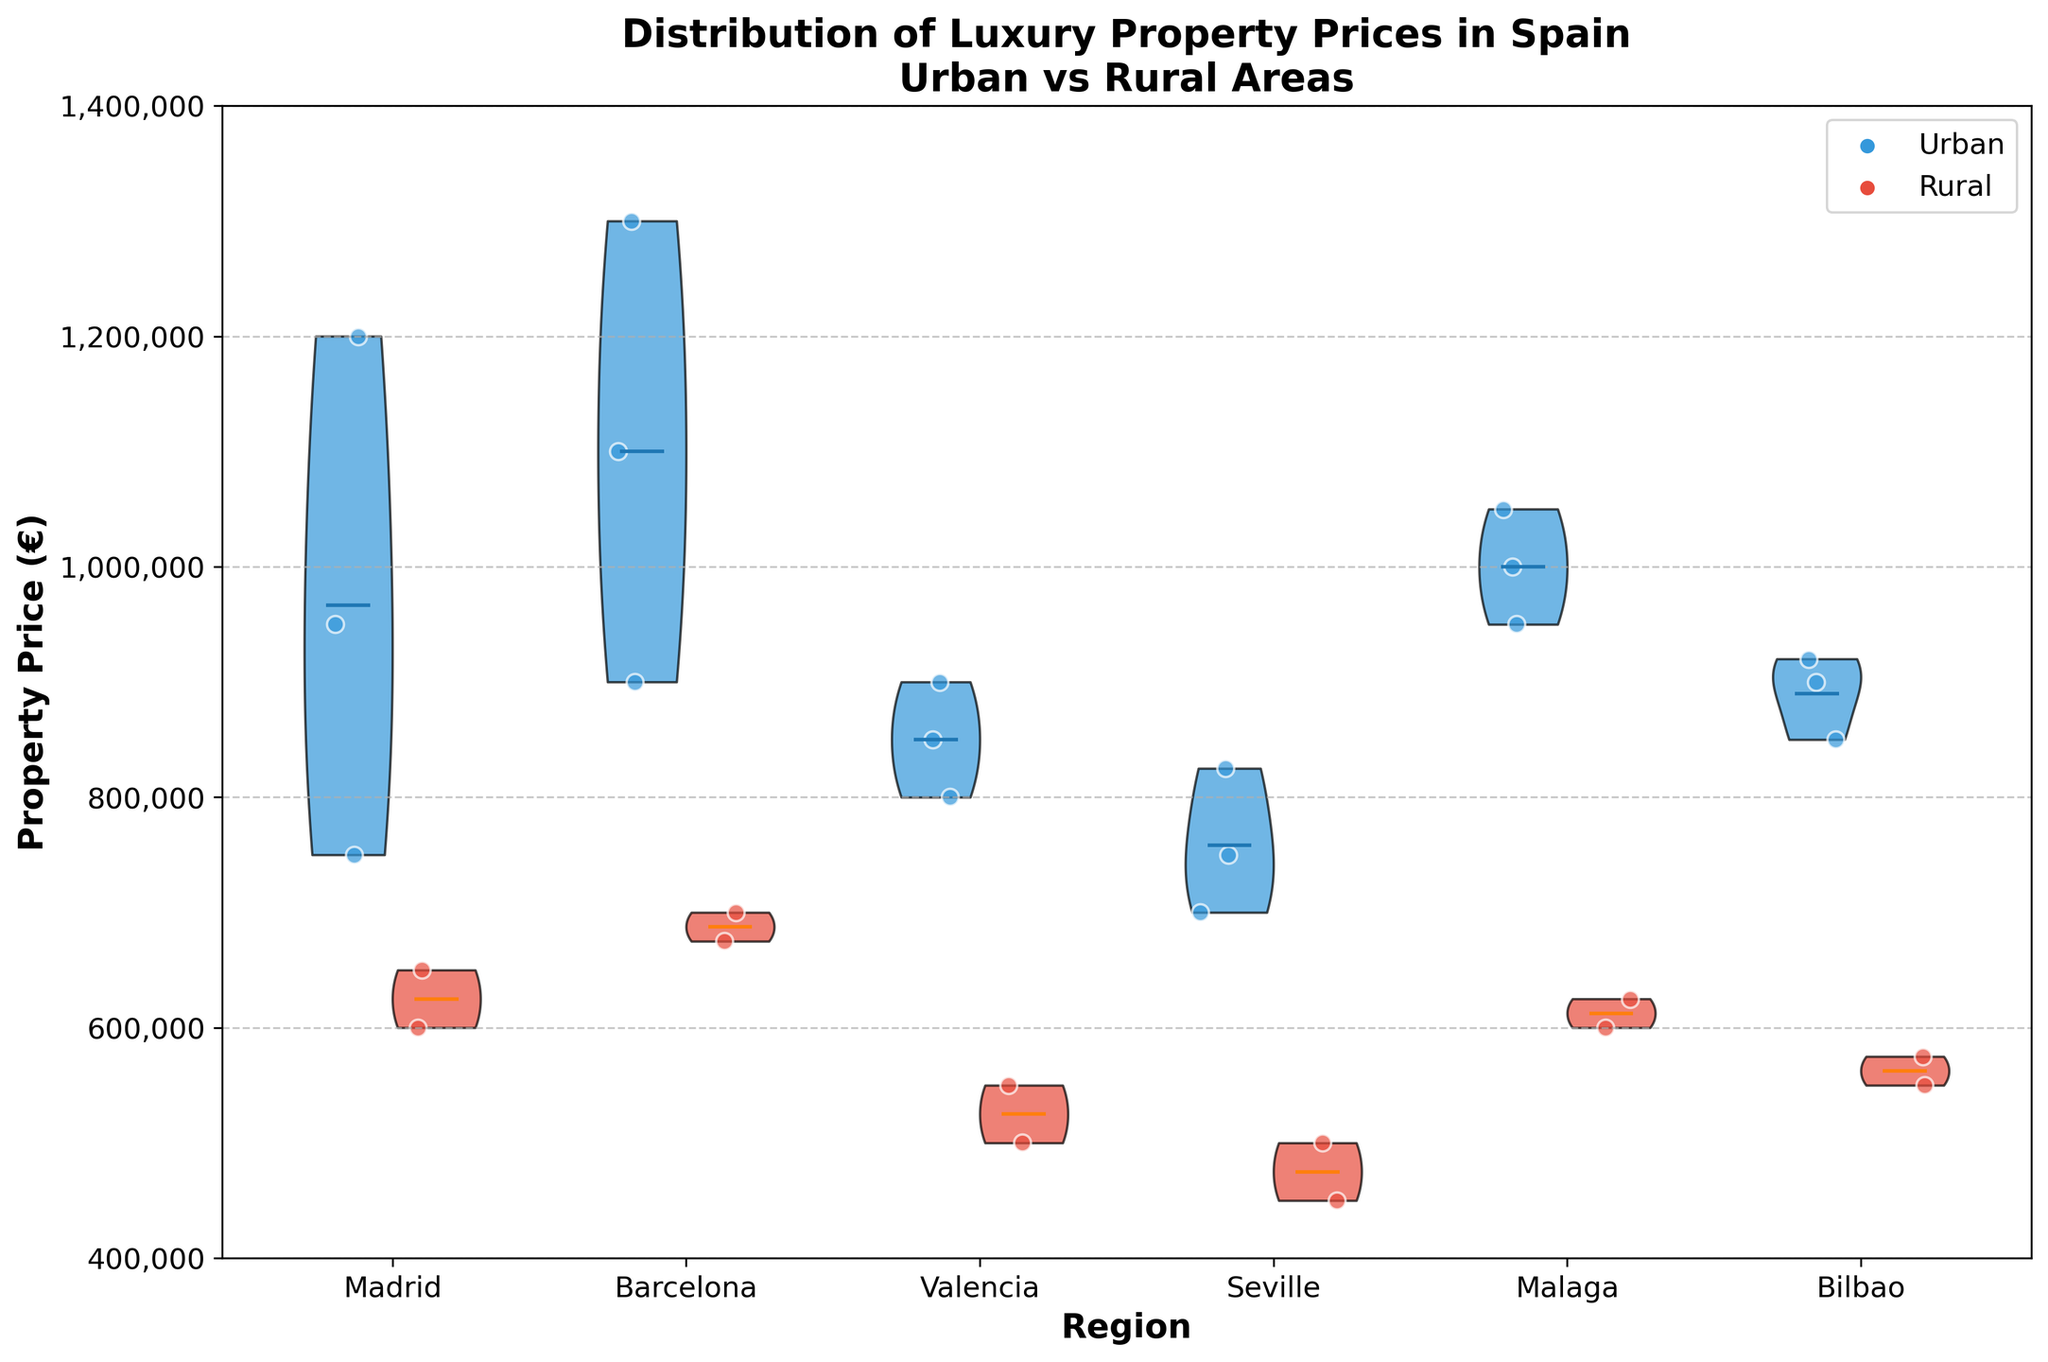What's the title of the plot? The title is located at the top of the chart, providing a summary of the visualized data.
Answer: Distribution of Luxury Property Prices in Spain\nUrban vs Rural Areas Which region shows the highest average property price in urban areas? The height and density of the violin plot for each region indicate the distribution of prices. The region with the highest mean represents the highest average.
Answer: Barcelona How do the rural property prices in Valencia compare to those in Seville? Examine the violin plots for the rural areas of Valencia and Seville. Compare the spreads and central tendencies of each plot.
Answer: Valencia's rural property prices are generally higher than Seville's What is the range of urban property prices for Madrid? Check the spread of jittered points within the urban section of Madrid's violin plot to determine the lowest and highest prices.
Answer: 750,000 to 1,200,000 euros How do the urban property prices in Malaga compare to Bilbao? Look at the violin plots for the urban areas of both Malaga and Bilbao. Compare their shapes, spreads, and central tendencies.
Answer: Malaga's urban property prices are higher than Bilbao’s What does the width of the violin plots indicate? The width of the violin plot represents the density of property prices at different values, indicating how frequently prices occur within the range.
Answer: Density of property prices Which rural area has the narrowest spread in property prices? Examine the violin plots for rural areas. The region with the narrowest plot represents the least variability in prices.
Answer: Seville Are there any regions where urban and rural prices overlap significantly? Look for regions where the urban and rural violin plots show overlapping densities and jittered points in terms of price ranges.
Answer: Yes, notably in Valencia Which region has the most significant difference in property prices between urban and rural areas? Assess the differences in central tendencies (means) and the overall spread between urban and rural violin plots for each region.
Answer: Madrid How are the jittered points used in this plot? Identify the role of jittered points, which add visualization of actual data points within the distribution shown by the violin plots.
Answer: Show individual property prices 